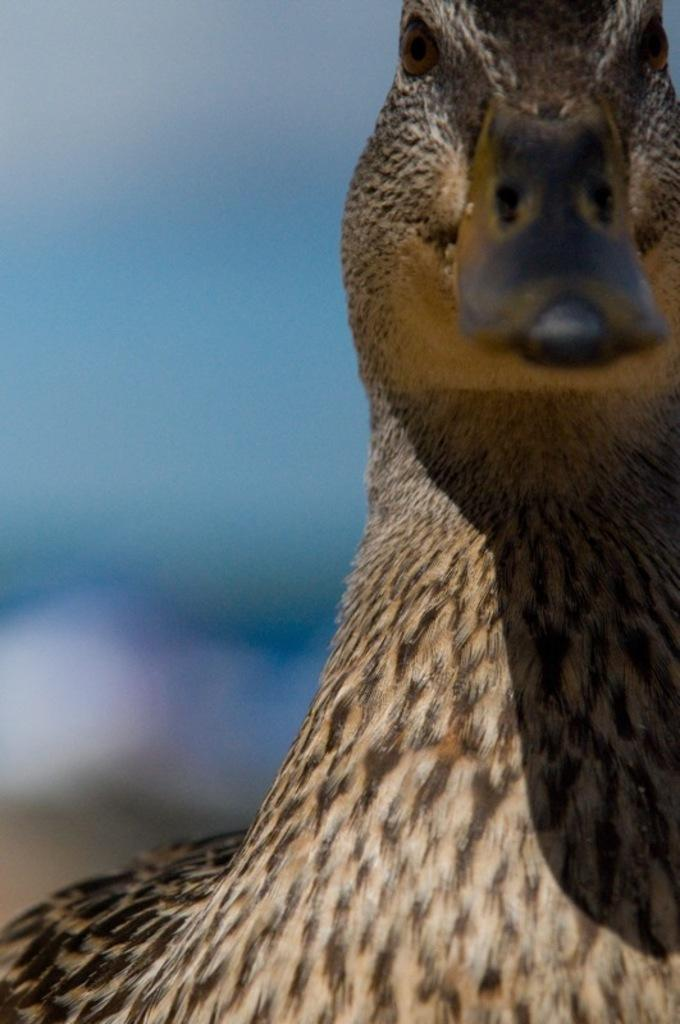What type of animal is present in the image? There is a duck in the image. Can you tell me how many people are jumping with the duck in the image? There are no people or jumping activities present in the image; it features a duck only. What type of container is being used by the duck in the image? There is no container, such as a pail, present in the image; it features a duck only. 